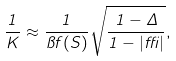Convert formula to latex. <formula><loc_0><loc_0><loc_500><loc_500>\frac { 1 } { K } \approx \frac { 1 } { \pi f ( S ) } \sqrt { \frac { 1 - \Delta } { 1 - | \delta | } } ,</formula> 